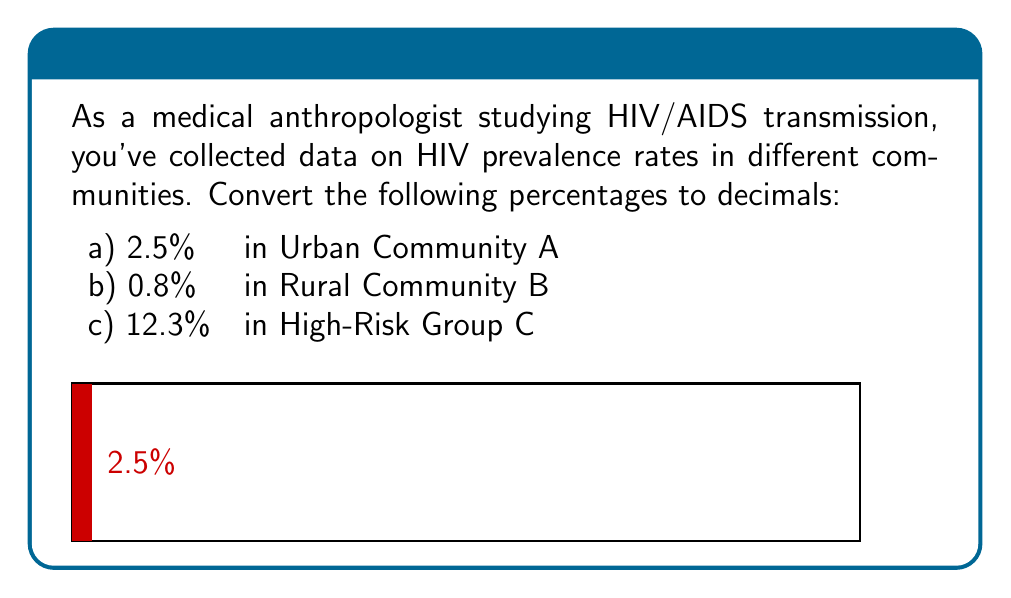Can you solve this math problem? To convert a percentage to a decimal, we divide the percentage by 100 or move the decimal point two places to the left. Let's convert each percentage:

a) For 2.5%:
   $\frac{2.5}{100} = 0.025$

b) For 0.8%:
   $\frac{0.8}{100} = 0.008$

c) For 12.3%:
   $\frac{12.3}{100} = 0.123$

In the context of HIV prevalence rates, these decimals represent the proportion of the population infected with HIV in each community. For example, 0.025 means that 25 out of every 1000 individuals in Urban Community A are HIV-positive.
Answer: a) 0.025
b) 0.008
c) 0.123 